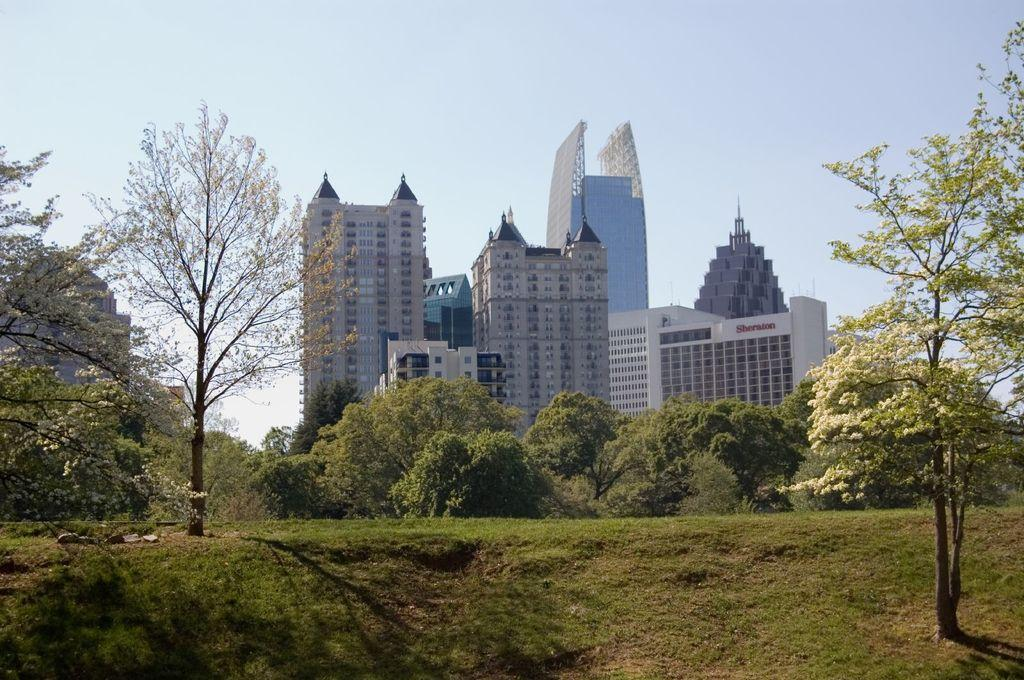What type of vegetation is present in the image? There is grass in the image. What other natural elements can be seen in the image? There are trees in the image. What type of structures are visible in the background of the image? There are buildings in the background of the image. What is visible at the top of the image? The sky is visible at the top of the image. What type of sheet is being used to cover the trees in the image? There is no sheet present in the image, and the trees are not covered. 